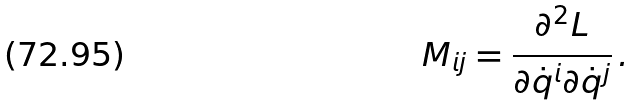Convert formula to latex. <formula><loc_0><loc_0><loc_500><loc_500>M _ { i j } = \frac { \partial ^ { 2 } L } { \partial \dot { q } ^ { i } \partial \dot { q } ^ { j } } \, .</formula> 